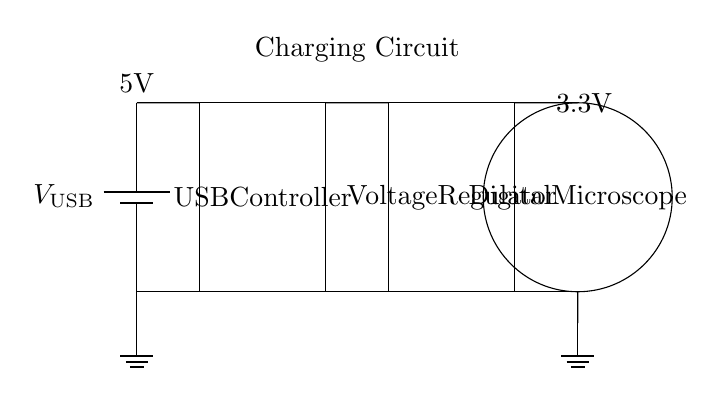What is the input voltage for the USB charging system? The input voltage is indicated at the USB power source, which is marked as 5V in the circuit diagram.
Answer: 5V What is the output voltage to the digital microscope? The output voltage is labeled on the connection leading to the digital microscope, which is shown as 3.3V.
Answer: 3.3V What component is responsible for converting 5V to 3.3V? The component that changes the voltage from 5V to 3.3V is the voltage regulator, which is specified in the circuit diagram.
Answer: Voltage Regulator How many main components are in the circuit? The circuit consists of three main components: battery (USB power source), USB controller, and voltage regulator.
Answer: Three What does the circular symbol in the circuit represent? The circular symbol in the circuit diagram represents the digital microscope, indicating where the output voltage is directed.
Answer: Digital Microscope What is the role of the USB controller in this circuit? The USB controller manages the power from the USB source and ensures that it is appropriately delivered to the voltage regulator and digital microscope.
Answer: Manage power What happens to the voltage as it passes through the voltage regulator? The voltage drops from 5V at the input to 3.3V at the output, which is necessary for the digital microscope's operation.
Answer: Voltage drops 